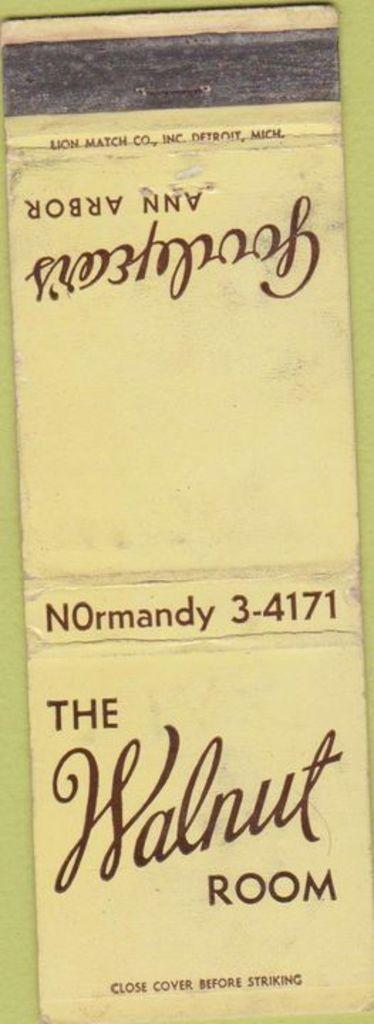<image>
Render a clear and concise summary of the photo. a faded yellow matchbook from the walnut room. 